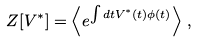<formula> <loc_0><loc_0><loc_500><loc_500>Z [ V ^ { * } ] = \left \langle e ^ { \int d t V ^ { * } ( t ) \phi ( t ) } \right \rangle \, ,</formula> 